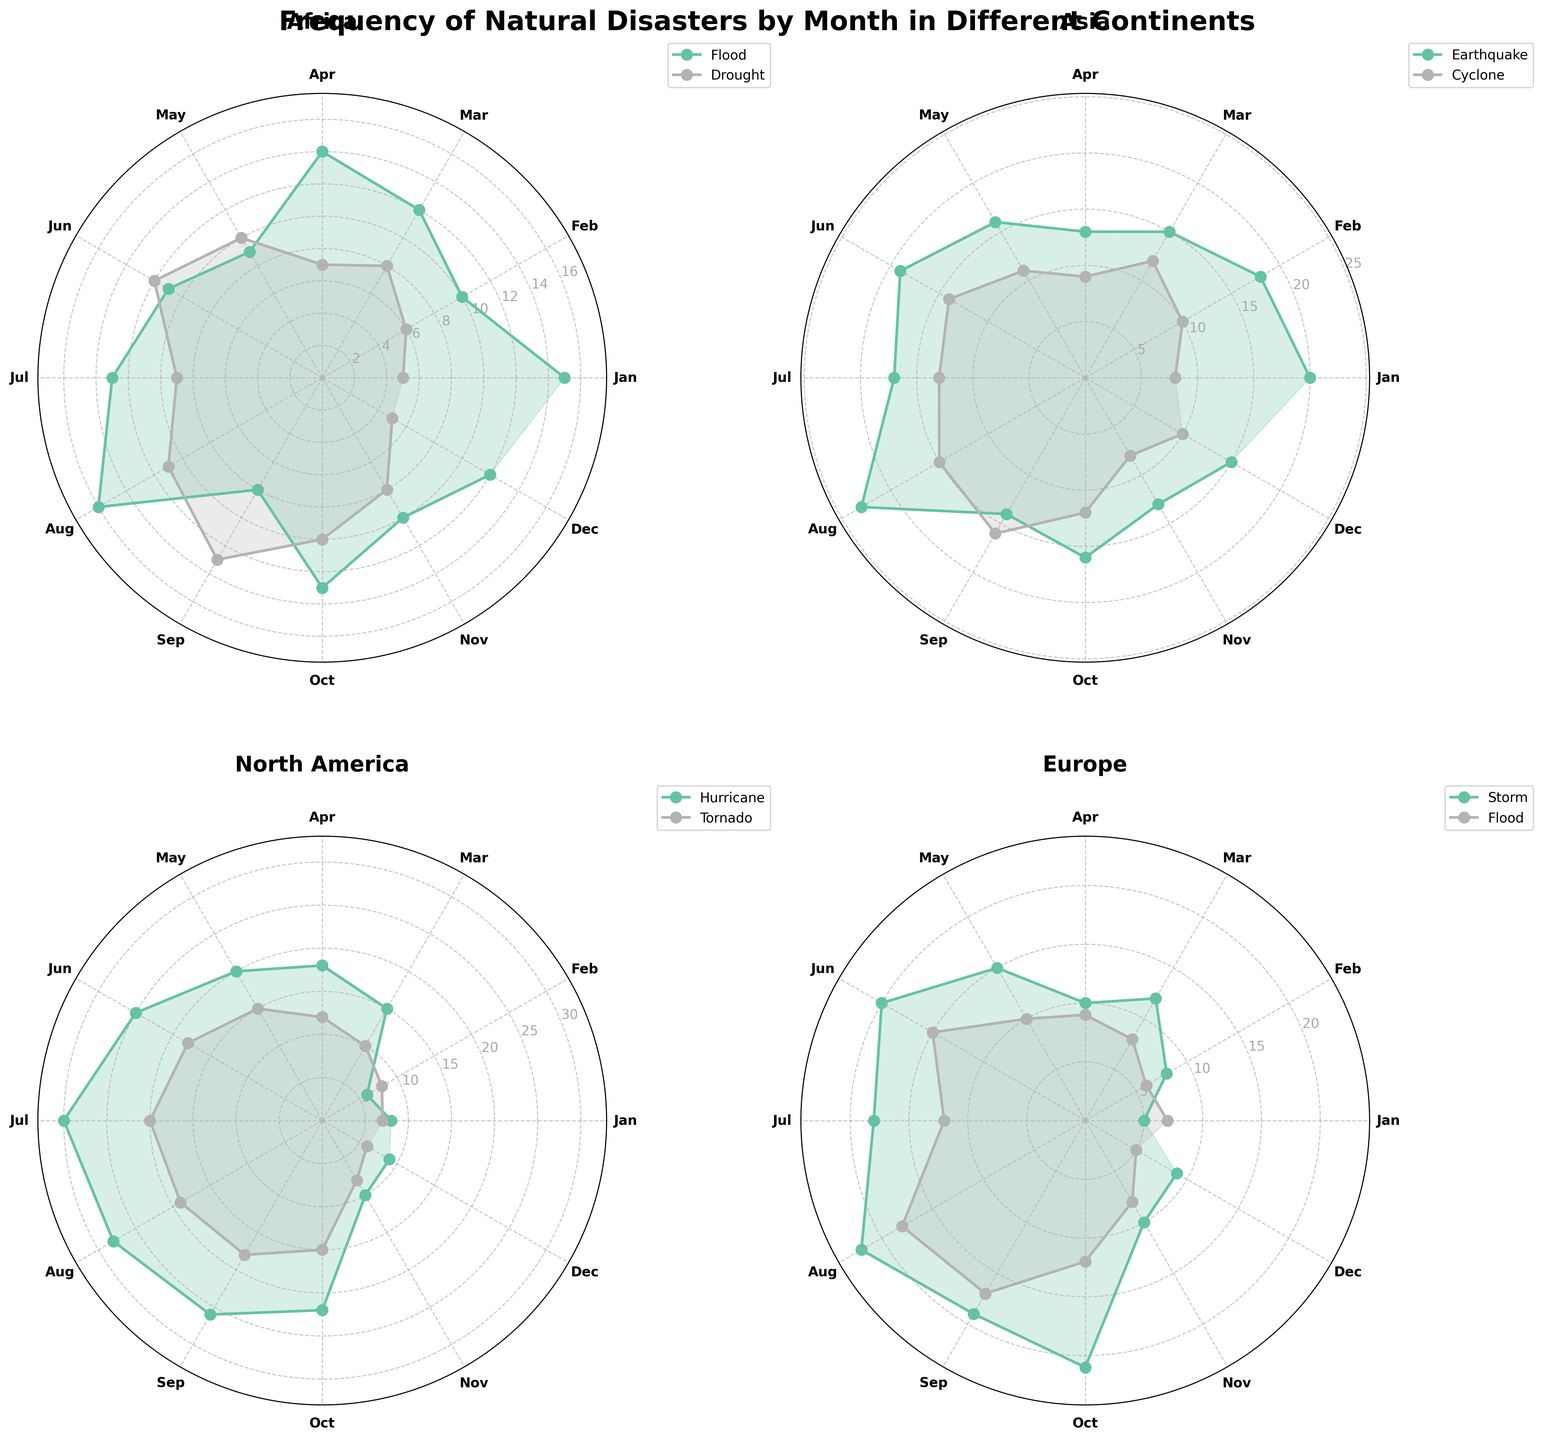What is the title of the plot? The title is usually displayed at the top of the figure. In this case, it specifically mentions the content of the figure
Answer: Frequency of Natural Disasters by Month in Different Continents Which continent has the highest frequency of natural disasters in August? Look at each subplot and check the values for August. The continent with the highest value is the answer
Answer: North America Which continent experienced the most frequent floods in April? Refer to the subplot for each continent and check the values for floods in April. Compare these values to determine the highest one
Answer: Africa Comparing drought occurrences in Africa, which month has a higher frequency, June or July? Locate the subplot for Africa, find the data points for drought in both June and July, and compare the values
Answer: June What is the common natural disaster in January in Europe? Check the labels in the subplot for Europe for January. Identify the natural disasters and compare their frequencies
Answer: Flood What is the difference in the frequency of Earthquakes in Asia between January and March? Identify the frequencies of Earthquakes in January and March in the Asia subplot. Subtract the March frequency from the January frequency
Answer: 5 On average, which month has the highest frequency of Tornadoes in North America? Locate the subplot for North America, find the frequencies of Tornadoes for each month, then calculate the average for each month. The highest average value gives the answer
Answer: July Which natural disaster has a higher frequency in October in Europe: Storm or Flood? Check the subplot for Europe in October and compare the frequencies of Storm and Flood
Answer: Storm Compare the maximum monthly frequency of Hurricanes in North America to Earthquakes in Asia. Which one is higher? Find the maximum monthly frequency of Hurricanes in the North America subplot and Earthquakes in the Asia subplot. Compare these two maximum values
Answer: Hurricanes in North America Are natural disasters more evenly distributed across months in Africa or Europe? Assess the frequency of natural disasters across the months in the subplots for Africa and Europe. One with less variation in frequencies indicates a more even distribution
Answer: Africa 